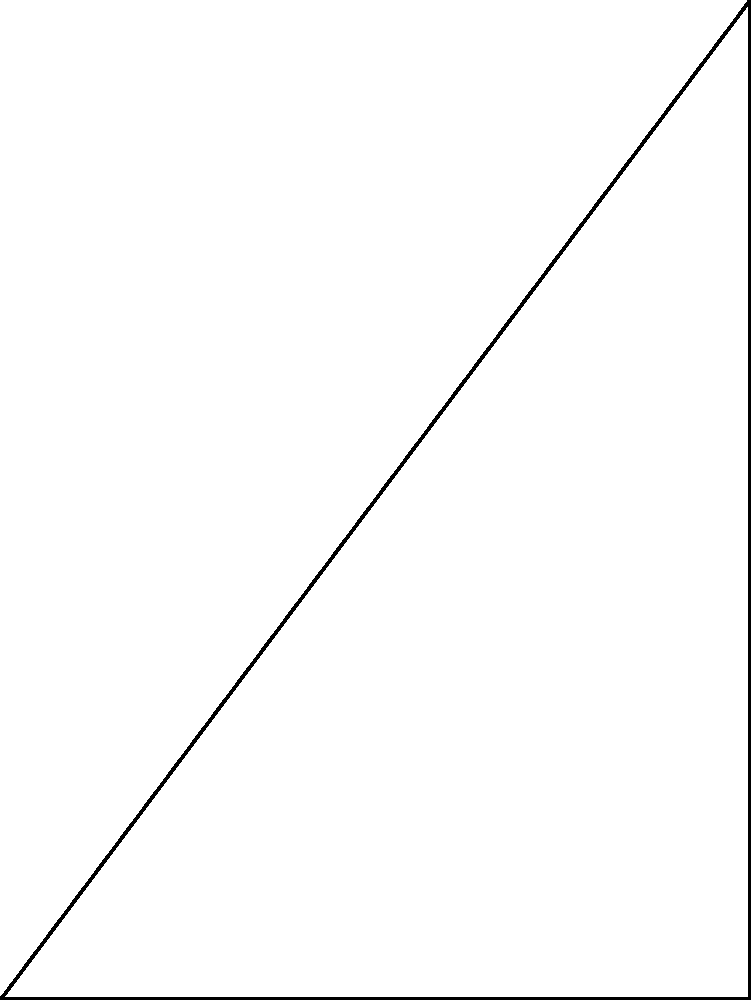In the design of a precise sundial for a synagogue courtyard, we need to calculate the angle of the shadow cast by a vertical gnomon (the part of the sundial that casts the shadow) at different times of the day. If the gnomon has a height of 4 cubits and casts a shadow with a length of 3 cubits, what is the angle $\theta$ (in degrees) between the ground and the sun's rays? Let's approach this step-by-step:

1) In the diagram, we have a right-angled triangle OAB, where:
   - O is the base of the gnomon
   - A is the end of the shadow
   - B is the top of the gnomon

2) We are given:
   - The height of the gnomon (OB) = 4 cubits
   - The length of the shadow (OA) = 3 cubits

3) We need to find the angle $\theta$ between the ground (OA) and the sun's rays (BA).

4) In a right-angled triangle, the tangent of an angle is the ratio of the opposite side to the adjacent side.

5) For angle $\theta$:
   - The opposite side is the height of the gnomon (OB)
   - The adjacent side is the length of the shadow (OA)

6) Therefore:

   $$\tan(\theta) = \frac{\text{opposite}}{\text{adjacent}} = \frac{\text{height of gnomon}}{\text{length of shadow}} = \frac{4}{3}$$

7) To find $\theta$, we need to take the inverse tangent (arctan or $\tan^{-1}$) of this ratio:

   $$\theta = \tan^{-1}(\frac{4}{3})$$

8) Using a calculator or trigonometric tables:

   $$\theta \approx 53.13010235415598^\circ$$

9) Rounding to two decimal places for practical use:

   $$\theta \approx 53.13^\circ$$

This angle represents the elevation of the sun above the horizon at the time when this shadow is cast.
Answer: $53.13^\circ$ 